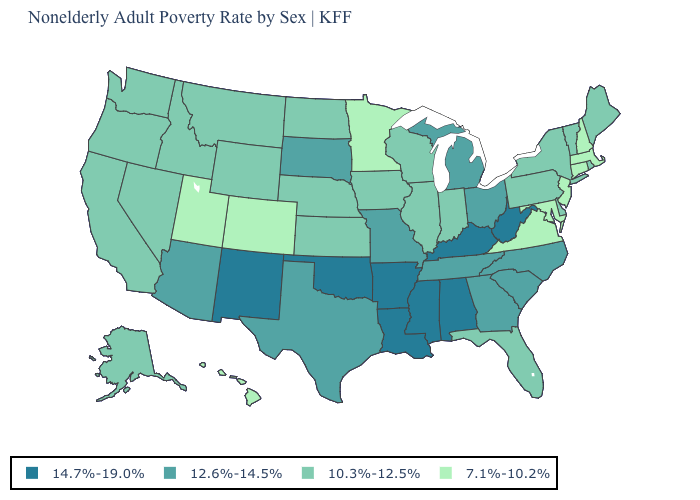Is the legend a continuous bar?
Write a very short answer. No. Which states hav the highest value in the South?
Concise answer only. Alabama, Arkansas, Kentucky, Louisiana, Mississippi, Oklahoma, West Virginia. How many symbols are there in the legend?
Short answer required. 4. Is the legend a continuous bar?
Keep it brief. No. Does the first symbol in the legend represent the smallest category?
Concise answer only. No. Name the states that have a value in the range 7.1%-10.2%?
Quick response, please. Colorado, Connecticut, Hawaii, Maryland, Massachusetts, Minnesota, New Hampshire, New Jersey, Utah, Virginia. Does Alaska have the highest value in the West?
Be succinct. No. Name the states that have a value in the range 10.3%-12.5%?
Short answer required. Alaska, California, Delaware, Florida, Idaho, Illinois, Indiana, Iowa, Kansas, Maine, Montana, Nebraska, Nevada, New York, North Dakota, Oregon, Pennsylvania, Rhode Island, Vermont, Washington, Wisconsin, Wyoming. Does North Carolina have a lower value than Oklahoma?
Short answer required. Yes. Does Wyoming have the highest value in the USA?
Write a very short answer. No. What is the value of Maryland?
Keep it brief. 7.1%-10.2%. What is the highest value in the USA?
Keep it brief. 14.7%-19.0%. Name the states that have a value in the range 10.3%-12.5%?
Be succinct. Alaska, California, Delaware, Florida, Idaho, Illinois, Indiana, Iowa, Kansas, Maine, Montana, Nebraska, Nevada, New York, North Dakota, Oregon, Pennsylvania, Rhode Island, Vermont, Washington, Wisconsin, Wyoming. What is the highest value in the USA?
Short answer required. 14.7%-19.0%. Name the states that have a value in the range 10.3%-12.5%?
Concise answer only. Alaska, California, Delaware, Florida, Idaho, Illinois, Indiana, Iowa, Kansas, Maine, Montana, Nebraska, Nevada, New York, North Dakota, Oregon, Pennsylvania, Rhode Island, Vermont, Washington, Wisconsin, Wyoming. 